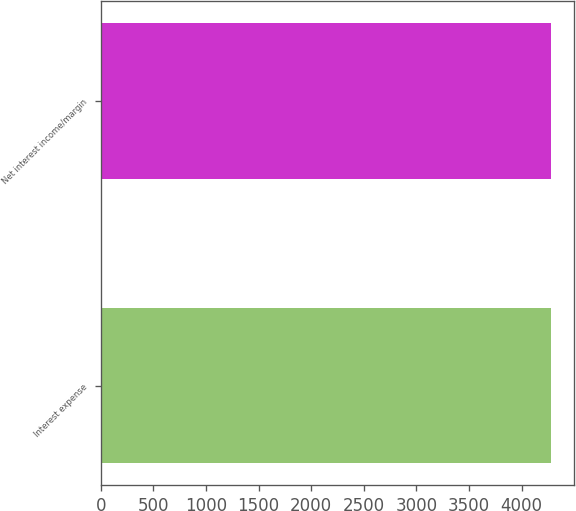Convert chart. <chart><loc_0><loc_0><loc_500><loc_500><bar_chart><fcel>Interest expense<fcel>Net interest income/margin<nl><fcel>4281<fcel>4281.1<nl></chart> 